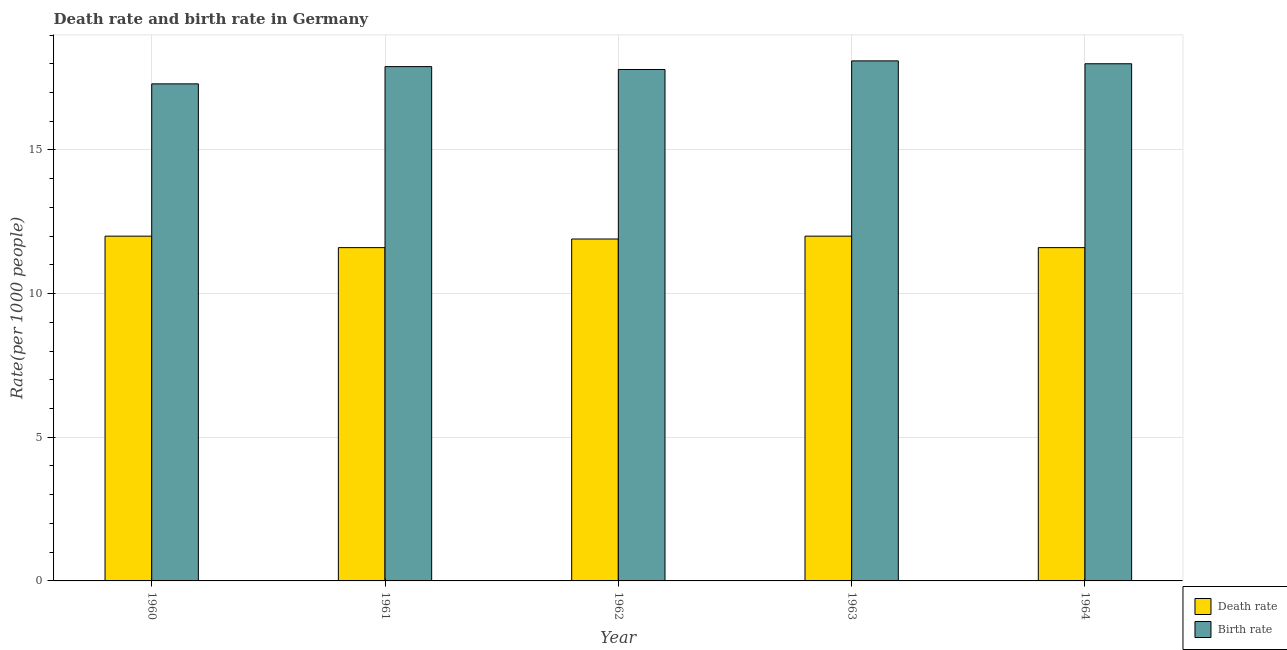Are the number of bars per tick equal to the number of legend labels?
Make the answer very short. Yes. What is the death rate in 1960?
Provide a succinct answer. 12. Across all years, what is the maximum birth rate?
Give a very brief answer. 18.1. In which year was the birth rate minimum?
Your answer should be very brief. 1960. What is the total birth rate in the graph?
Keep it short and to the point. 89.1. What is the difference between the birth rate in 1960 and that in 1964?
Your response must be concise. -0.7. What is the difference between the death rate in 1961 and the birth rate in 1964?
Provide a short and direct response. 0. What is the average birth rate per year?
Your answer should be very brief. 17.82. What is the ratio of the death rate in 1960 to that in 1962?
Provide a succinct answer. 1.01. What is the difference between the highest and the lowest death rate?
Offer a terse response. 0.4. What does the 1st bar from the left in 1964 represents?
Your answer should be compact. Death rate. What does the 2nd bar from the right in 1963 represents?
Your answer should be very brief. Death rate. Are all the bars in the graph horizontal?
Your answer should be very brief. No. What is the difference between two consecutive major ticks on the Y-axis?
Keep it short and to the point. 5. Where does the legend appear in the graph?
Ensure brevity in your answer.  Bottom right. How many legend labels are there?
Offer a terse response. 2. How are the legend labels stacked?
Your response must be concise. Vertical. What is the title of the graph?
Make the answer very short. Death rate and birth rate in Germany. What is the label or title of the Y-axis?
Offer a terse response. Rate(per 1000 people). What is the Rate(per 1000 people) of Death rate in 1960?
Provide a short and direct response. 12. What is the Rate(per 1000 people) in Birth rate in 1960?
Your response must be concise. 17.3. What is the Rate(per 1000 people) in Death rate in 1961?
Make the answer very short. 11.6. What is the Rate(per 1000 people) of Birth rate in 1961?
Your answer should be compact. 17.9. What is the Rate(per 1000 people) of Death rate in 1963?
Offer a very short reply. 12. What is the Rate(per 1000 people) of Birth rate in 1963?
Your answer should be compact. 18.1. What is the Rate(per 1000 people) in Birth rate in 1964?
Offer a terse response. 18. Across all years, what is the maximum Rate(per 1000 people) of Birth rate?
Your answer should be very brief. 18.1. Across all years, what is the minimum Rate(per 1000 people) in Birth rate?
Provide a succinct answer. 17.3. What is the total Rate(per 1000 people) of Death rate in the graph?
Provide a succinct answer. 59.1. What is the total Rate(per 1000 people) in Birth rate in the graph?
Offer a terse response. 89.1. What is the difference between the Rate(per 1000 people) in Death rate in 1960 and that in 1961?
Your response must be concise. 0.4. What is the difference between the Rate(per 1000 people) in Birth rate in 1960 and that in 1961?
Provide a succinct answer. -0.6. What is the difference between the Rate(per 1000 people) of Birth rate in 1960 and that in 1962?
Your answer should be very brief. -0.5. What is the difference between the Rate(per 1000 people) in Birth rate in 1960 and that in 1963?
Offer a very short reply. -0.8. What is the difference between the Rate(per 1000 people) in Death rate in 1961 and that in 1962?
Your answer should be compact. -0.3. What is the difference between the Rate(per 1000 people) of Death rate in 1961 and that in 1963?
Keep it short and to the point. -0.4. What is the difference between the Rate(per 1000 people) in Birth rate in 1961 and that in 1963?
Offer a very short reply. -0.2. What is the difference between the Rate(per 1000 people) of Death rate in 1961 and that in 1964?
Make the answer very short. 0. What is the difference between the Rate(per 1000 people) of Birth rate in 1962 and that in 1963?
Ensure brevity in your answer.  -0.3. What is the difference between the Rate(per 1000 people) of Death rate in 1962 and that in 1964?
Keep it short and to the point. 0.3. What is the difference between the Rate(per 1000 people) in Death rate in 1963 and that in 1964?
Give a very brief answer. 0.4. What is the difference between the Rate(per 1000 people) of Death rate in 1960 and the Rate(per 1000 people) of Birth rate in 1962?
Offer a terse response. -5.8. What is the difference between the Rate(per 1000 people) of Death rate in 1960 and the Rate(per 1000 people) of Birth rate in 1963?
Your answer should be compact. -6.1. What is the difference between the Rate(per 1000 people) in Death rate in 1960 and the Rate(per 1000 people) in Birth rate in 1964?
Offer a very short reply. -6. What is the difference between the Rate(per 1000 people) in Death rate in 1961 and the Rate(per 1000 people) in Birth rate in 1963?
Ensure brevity in your answer.  -6.5. What is the difference between the Rate(per 1000 people) in Death rate in 1962 and the Rate(per 1000 people) in Birth rate in 1964?
Make the answer very short. -6.1. What is the average Rate(per 1000 people) of Death rate per year?
Give a very brief answer. 11.82. What is the average Rate(per 1000 people) in Birth rate per year?
Your answer should be very brief. 17.82. In the year 1960, what is the difference between the Rate(per 1000 people) of Death rate and Rate(per 1000 people) of Birth rate?
Your answer should be compact. -5.3. In the year 1961, what is the difference between the Rate(per 1000 people) in Death rate and Rate(per 1000 people) in Birth rate?
Offer a terse response. -6.3. In the year 1964, what is the difference between the Rate(per 1000 people) of Death rate and Rate(per 1000 people) of Birth rate?
Your answer should be compact. -6.4. What is the ratio of the Rate(per 1000 people) of Death rate in 1960 to that in 1961?
Provide a succinct answer. 1.03. What is the ratio of the Rate(per 1000 people) in Birth rate in 1960 to that in 1961?
Make the answer very short. 0.97. What is the ratio of the Rate(per 1000 people) of Death rate in 1960 to that in 1962?
Keep it short and to the point. 1.01. What is the ratio of the Rate(per 1000 people) of Birth rate in 1960 to that in 1962?
Give a very brief answer. 0.97. What is the ratio of the Rate(per 1000 people) in Birth rate in 1960 to that in 1963?
Make the answer very short. 0.96. What is the ratio of the Rate(per 1000 people) of Death rate in 1960 to that in 1964?
Make the answer very short. 1.03. What is the ratio of the Rate(per 1000 people) of Birth rate in 1960 to that in 1964?
Make the answer very short. 0.96. What is the ratio of the Rate(per 1000 people) in Death rate in 1961 to that in 1962?
Offer a very short reply. 0.97. What is the ratio of the Rate(per 1000 people) of Birth rate in 1961 to that in 1962?
Provide a succinct answer. 1.01. What is the ratio of the Rate(per 1000 people) of Death rate in 1961 to that in 1963?
Keep it short and to the point. 0.97. What is the ratio of the Rate(per 1000 people) of Birth rate in 1962 to that in 1963?
Make the answer very short. 0.98. What is the ratio of the Rate(per 1000 people) in Death rate in 1962 to that in 1964?
Ensure brevity in your answer.  1.03. What is the ratio of the Rate(per 1000 people) of Birth rate in 1962 to that in 1964?
Keep it short and to the point. 0.99. What is the ratio of the Rate(per 1000 people) in Death rate in 1963 to that in 1964?
Make the answer very short. 1.03. What is the ratio of the Rate(per 1000 people) of Birth rate in 1963 to that in 1964?
Provide a short and direct response. 1.01. What is the difference between the highest and the lowest Rate(per 1000 people) in Death rate?
Give a very brief answer. 0.4. 